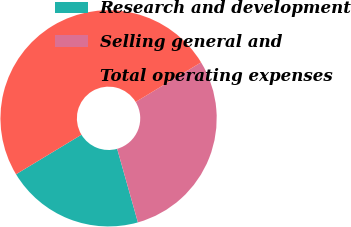<chart> <loc_0><loc_0><loc_500><loc_500><pie_chart><fcel>Research and development<fcel>Selling general and<fcel>Total operating expenses<nl><fcel>20.72%<fcel>29.28%<fcel>50.0%<nl></chart> 